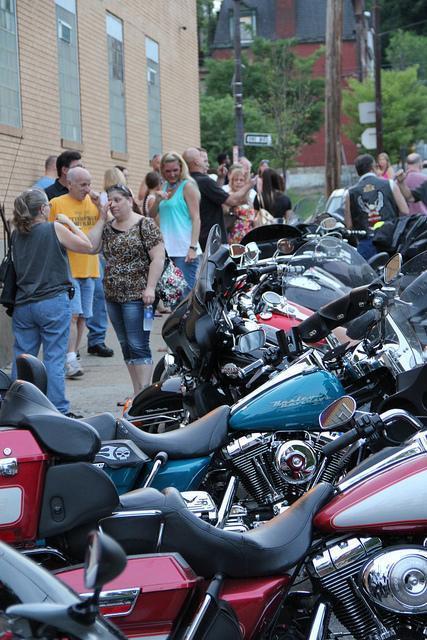How many bikers are wearing leather clothing?
Give a very brief answer. 1. How many people are there?
Give a very brief answer. 7. How many motorcycles can you see?
Give a very brief answer. 2. 